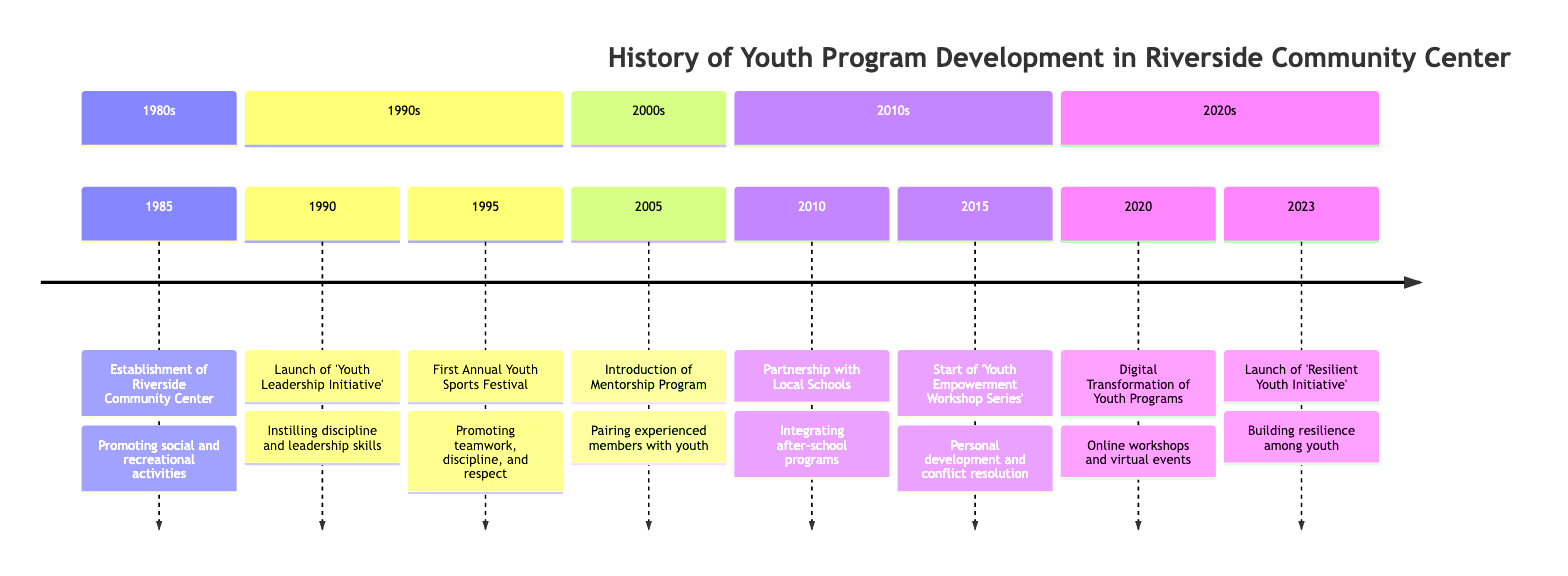What year was the Riverside Community Center established? From the timeline, the first event listed is the establishment of the Riverside Community Center, which is noted to occur in 1985.
Answer: 1985 What initiative was launched in 1990? The timeline shows that in 1990, the 'Youth Leadership Initiative' was launched, indicating the specific program started that year.
Answer: Youth Leadership Initiative How many key milestones are listed in the timeline? By counting each event in the timeline, there are a total of 8 key milestones documented from 1985 to 2023.
Answer: 8 What was the focus of the 2005 program? In the timeline for 2005, it mentions the introduction of a Mentorship Program, which focuses on pairing experienced community members with youth.
Answer: Mentorship Program Which event in 2015 aimed to empower youth? The timeline indicates that in 2015, the 'Youth Empowerment Workshop Series' was started, focusing explicitly on personal development, conflict resolution, and community involvement for youth.
Answer: Youth Empowerment Workshop Series What was the main goal of the partnership formed in 2010? According to the timeline, the partnership with local schools in 2010 aimed at integrating after-school programs that promote discipline and respect through structured activities.
Answer: Promoting discipline and respect Which decade saw the launch of the first Annual Youth Sports Festival? The timeline categorizes events by decade, showing that the first Annual Youth Sports Festival was launched in the 1990s (specifically in 1995).
Answer: 1990s What is the name of the initiative launched in 2023? The last event listed in the timeline for the year 2023 is the 'Resilient Youth Initiative', indicating the focus of new programming introduced that year.
Answer: Resilient Youth Initiative 